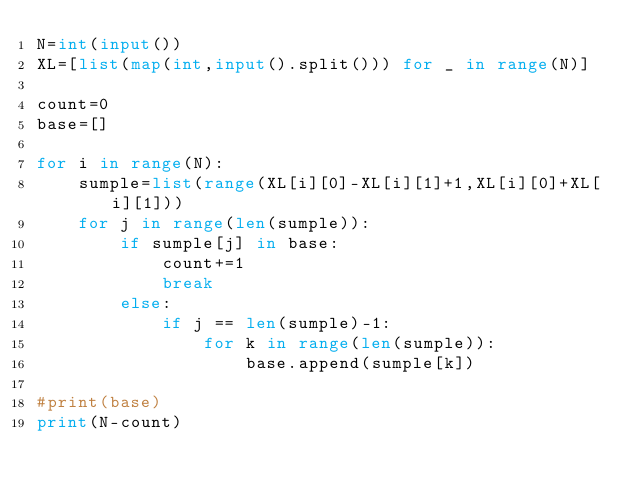<code> <loc_0><loc_0><loc_500><loc_500><_Python_>N=int(input())
XL=[list(map(int,input().split())) for _ in range(N)]

count=0
base=[]

for i in range(N):
    sumple=list(range(XL[i][0]-XL[i][1]+1,XL[i][0]+XL[i][1]))
    for j in range(len(sumple)):
        if sumple[j] in base:
            count+=1
            break
        else:
            if j == len(sumple)-1:
                for k in range(len(sumple)):
                    base.append(sumple[k])

#print(base)
print(N-count)</code> 